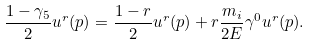<formula> <loc_0><loc_0><loc_500><loc_500>\frac { 1 - \gamma _ { 5 } } { 2 } u ^ { r } ( p ) = \frac { 1 - r } { 2 } u ^ { r } ( p ) + r \frac { m _ { i } } { 2 E } \gamma ^ { 0 } u ^ { r } ( p ) .</formula> 